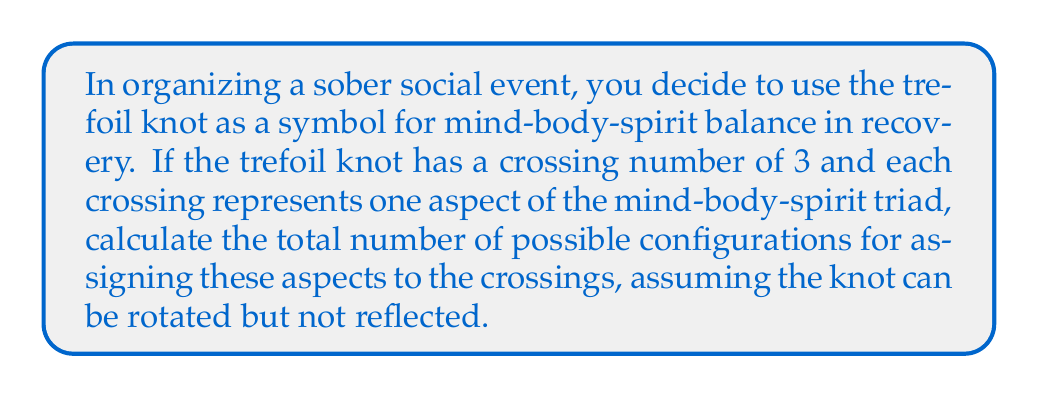Help me with this question. Let's approach this step-by-step:

1) The trefoil knot has 3 crossings, which can be represented as:

   [asy]
   import geometry;

   size(100);
   
   path p = (0,0)..(1,1)..(0,2)..(-1,1)..(0,0);
   path q = p rotated 120;
   path r = q rotated 120;

   draw(p);
   draw(q);
   draw(r);

   dot((0,0));
   dot((cos(2*pi/3), sin(2*pi/3)));
   dot((cos(4*pi/3), sin(4*pi/3)));
   [/asy]

2) We need to assign 3 aspects (mind, body, spirit) to these 3 crossings.

3) This is a permutation problem. Normally, with 3 elements, we would have $3! = 6$ permutations.

4) However, the question states that the knot can be rotated. This means that some permutations will be equivalent under rotation.

5) The trefoil knot has a rotational symmetry of order 3. This means that each unique configuration can be rotated to produce two other equivalent configurations.

6) Therefore, we need to divide the total number of permutations by 3:

   $$ \text{Number of unique configurations} = \frac{3!}{3} = \frac{6}{3} = 2 $$

7) These two unique configurations can be represented as:
   - Mind -> Body -> Spirit
   - Mind -> Spirit -> Body

   All other configurations are rotations of these two.
Answer: 2 